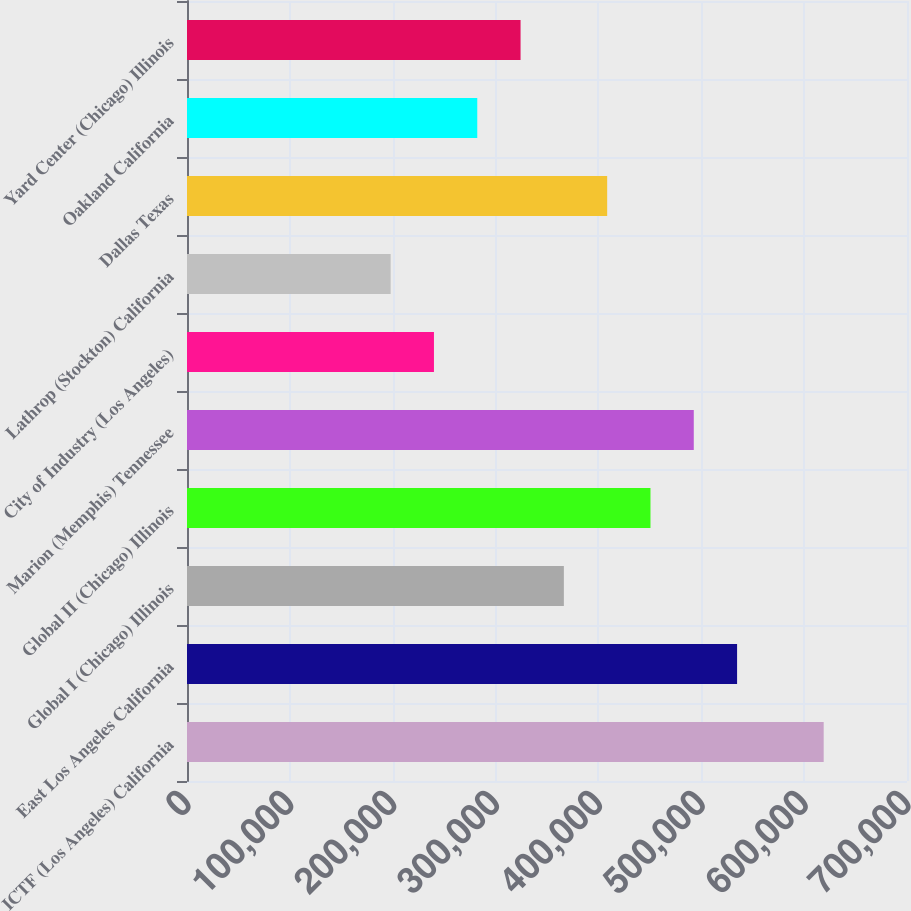Convert chart to OTSL. <chart><loc_0><loc_0><loc_500><loc_500><bar_chart><fcel>ICTF (Los Angeles) California<fcel>East Los Angeles California<fcel>Global I (Chicago) Illinois<fcel>Global II (Chicago) Illinois<fcel>Marion (Memphis) Tennessee<fcel>City of Industry (Los Angeles)<fcel>Lathrop (Stockton) California<fcel>Dallas Texas<fcel>Oakland California<fcel>Yard Center (Chicago) Illinois<nl><fcel>619000<fcel>534800<fcel>366400<fcel>450600<fcel>492700<fcel>240100<fcel>198000<fcel>408500<fcel>282200<fcel>324300<nl></chart> 